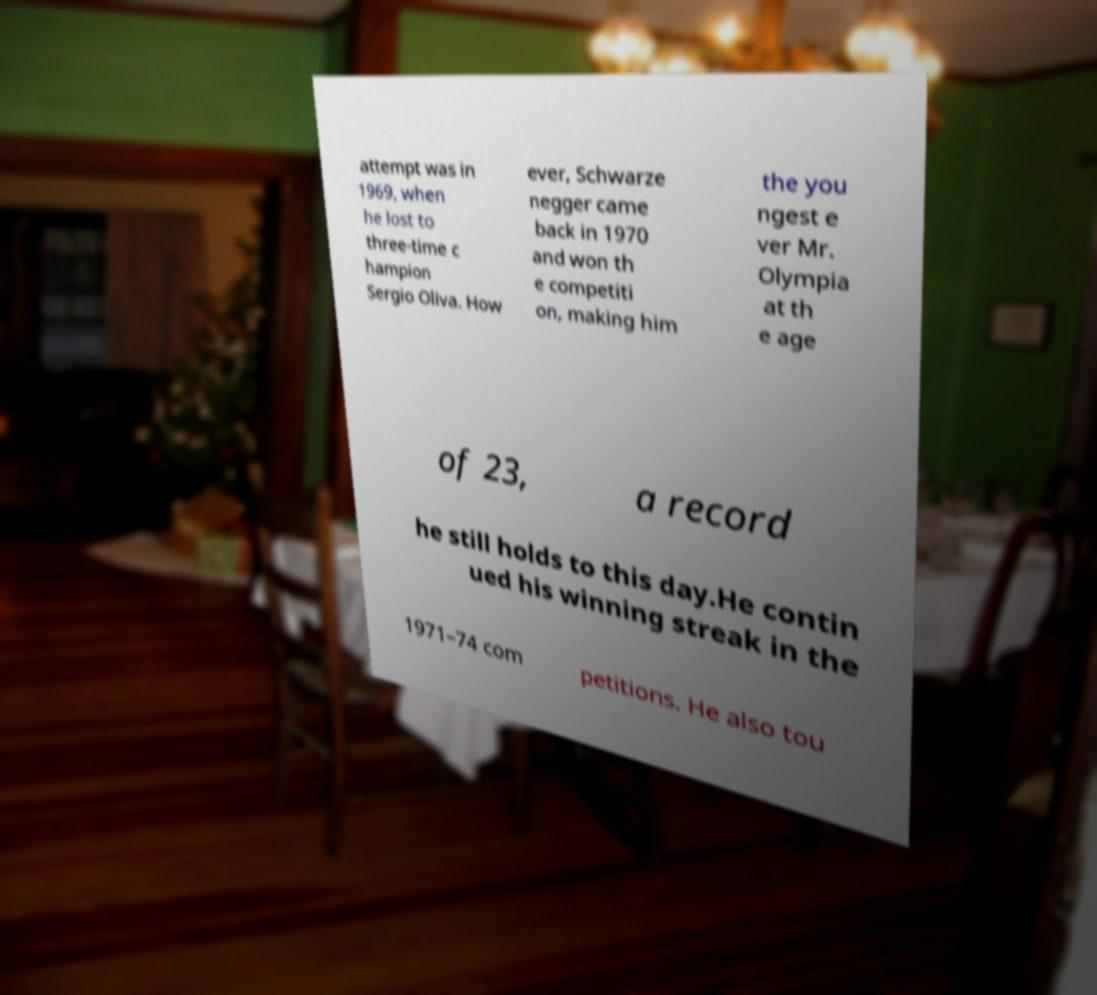There's text embedded in this image that I need extracted. Can you transcribe it verbatim? attempt was in 1969, when he lost to three-time c hampion Sergio Oliva. How ever, Schwarze negger came back in 1970 and won th e competiti on, making him the you ngest e ver Mr. Olympia at th e age of 23, a record he still holds to this day.He contin ued his winning streak in the 1971–74 com petitions. He also tou 